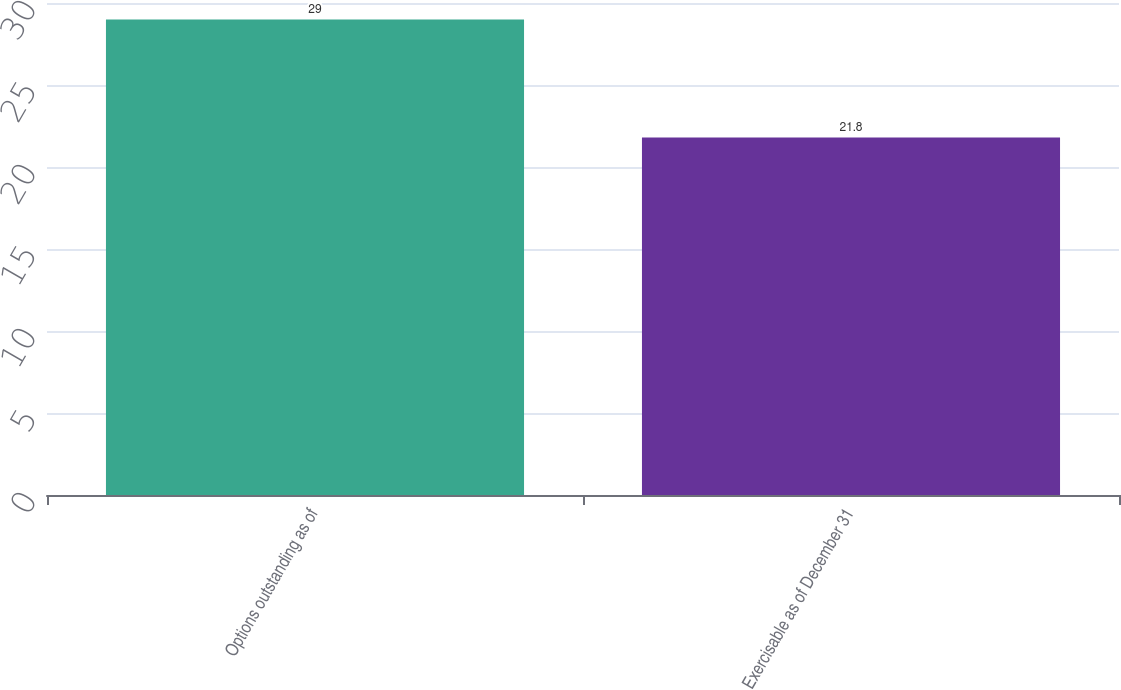Convert chart to OTSL. <chart><loc_0><loc_0><loc_500><loc_500><bar_chart><fcel>Options outstanding as of<fcel>Exercisable as of December 31<nl><fcel>29<fcel>21.8<nl></chart> 